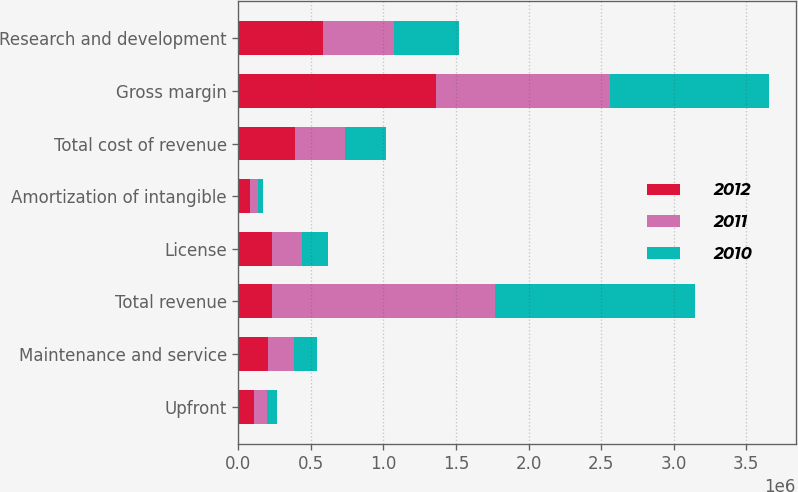Convert chart. <chart><loc_0><loc_0><loc_500><loc_500><stacked_bar_chart><ecel><fcel>Upfront<fcel>Maintenance and service<fcel>Total revenue<fcel>License<fcel>Amortization of intangible<fcel>Total cost of revenue<fcel>Gross margin<fcel>Research and development<nl><fcel>2012<fcel>105137<fcel>201580<fcel>232811<fcel>232811<fcel>81255<fcel>392673<fcel>1.36334e+06<fcel>581628<nl><fcel>2011<fcel>90531<fcel>184770<fcel>1.53564e+06<fcel>205390<fcel>54819<fcel>340450<fcel>1.19519e+06<fcel>491871<nl><fcel>2010<fcel>68618<fcel>153625<fcel>1.38066e+06<fcel>180245<fcel>36103<fcel>281094<fcel>1.09957e+06<fcel>449229<nl></chart> 